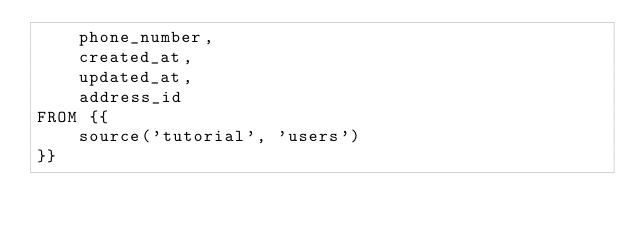<code> <loc_0><loc_0><loc_500><loc_500><_SQL_>    phone_number,
    created_at,
    updated_at,
    address_id
FROM {{
    source('tutorial', 'users')
}}</code> 